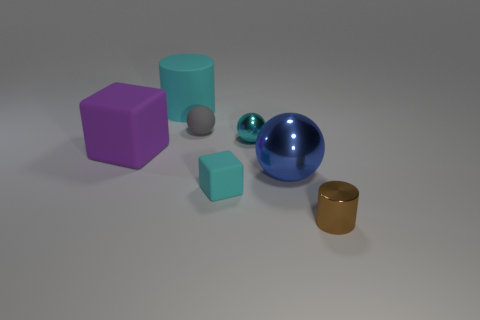Add 2 tiny metallic balls. How many objects exist? 9 Subtract all blocks. How many objects are left? 5 Subtract all tiny brown things. Subtract all cyan shiny things. How many objects are left? 5 Add 5 balls. How many balls are left? 8 Add 7 small gray matte balls. How many small gray matte balls exist? 8 Subtract 0 purple cylinders. How many objects are left? 7 